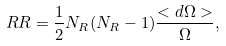<formula> <loc_0><loc_0><loc_500><loc_500>R R = \frac { 1 } { 2 } N _ { R } ( N _ { R } - 1 ) \frac { < d \Omega > } { \Omega } ,</formula> 